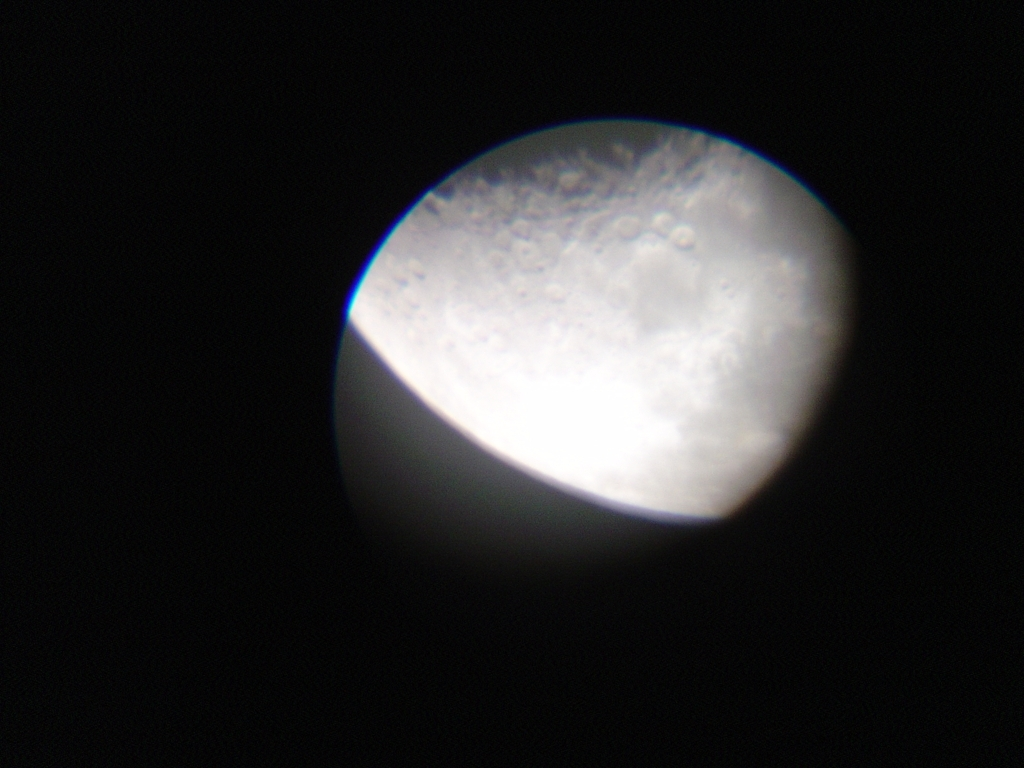How would you rate the quality of this image? The quality of the image is below average due to the blurriness and lack of sharpness, likely a result of using low-resolution equipment or an unsteady hand. While the subject, which appears to be the Moon, is recognizable, the details are not clear enough to provide a satisfying visual experience. 